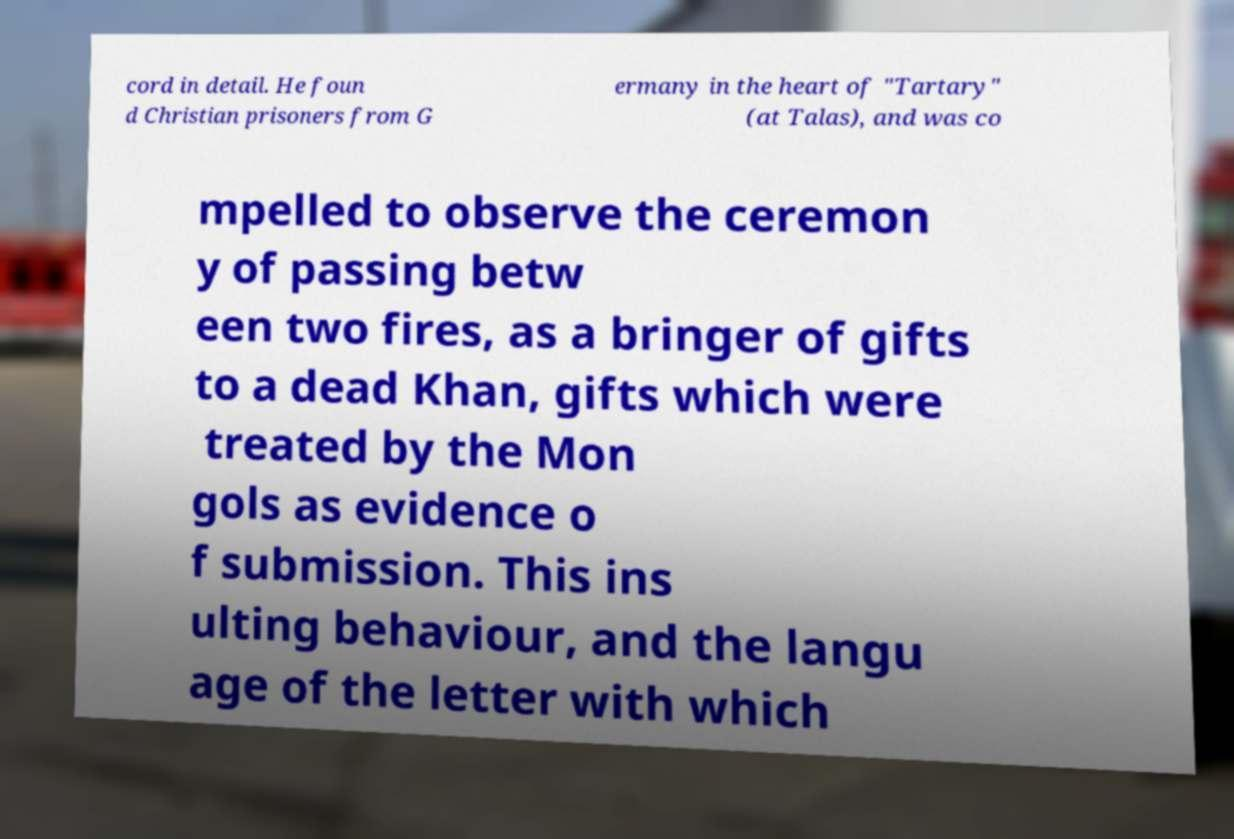Please read and relay the text visible in this image. What does it say? cord in detail. He foun d Christian prisoners from G ermany in the heart of "Tartary" (at Talas), and was co mpelled to observe the ceremon y of passing betw een two fires, as a bringer of gifts to a dead Khan, gifts which were treated by the Mon gols as evidence o f submission. This ins ulting behaviour, and the langu age of the letter with which 